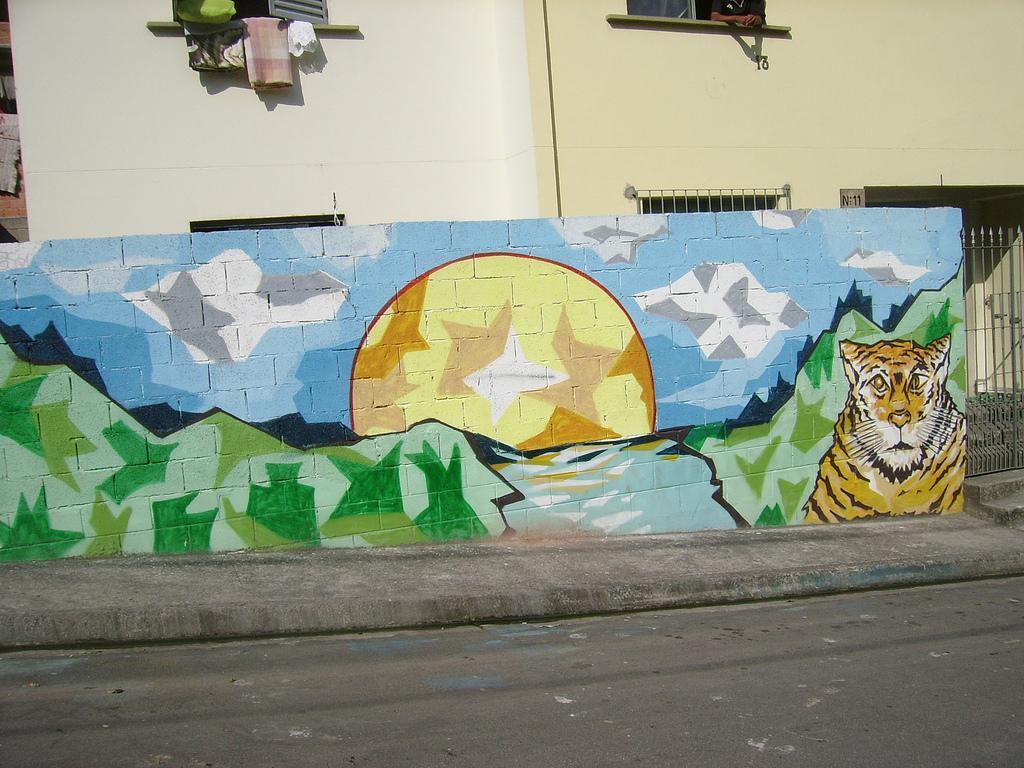In one or two sentences, can you explain what this image depicts? Painting is on wall. In-front of this window there are clothes. Here we can see a person hands.  